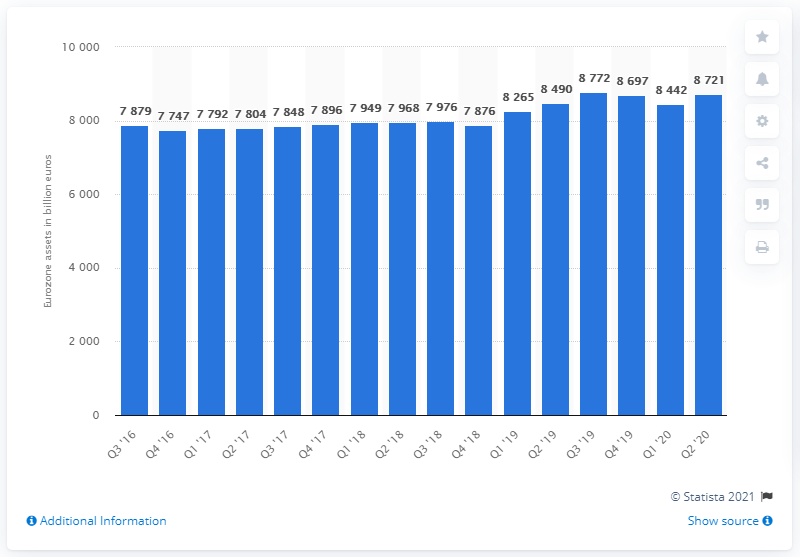Outline some significant characteristics in this image. The total assets of insurance corporations in the second quarter of 2020 were 8,721. 